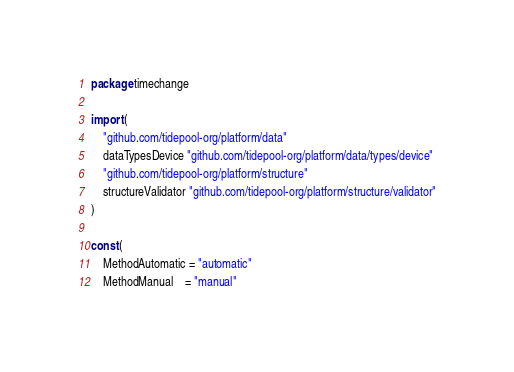Convert code to text. <code><loc_0><loc_0><loc_500><loc_500><_Go_>package timechange

import (
	"github.com/tidepool-org/platform/data"
	dataTypesDevice "github.com/tidepool-org/platform/data/types/device"
	"github.com/tidepool-org/platform/structure"
	structureValidator "github.com/tidepool-org/platform/structure/validator"
)

const (
	MethodAutomatic = "automatic"
	MethodManual    = "manual"</code> 